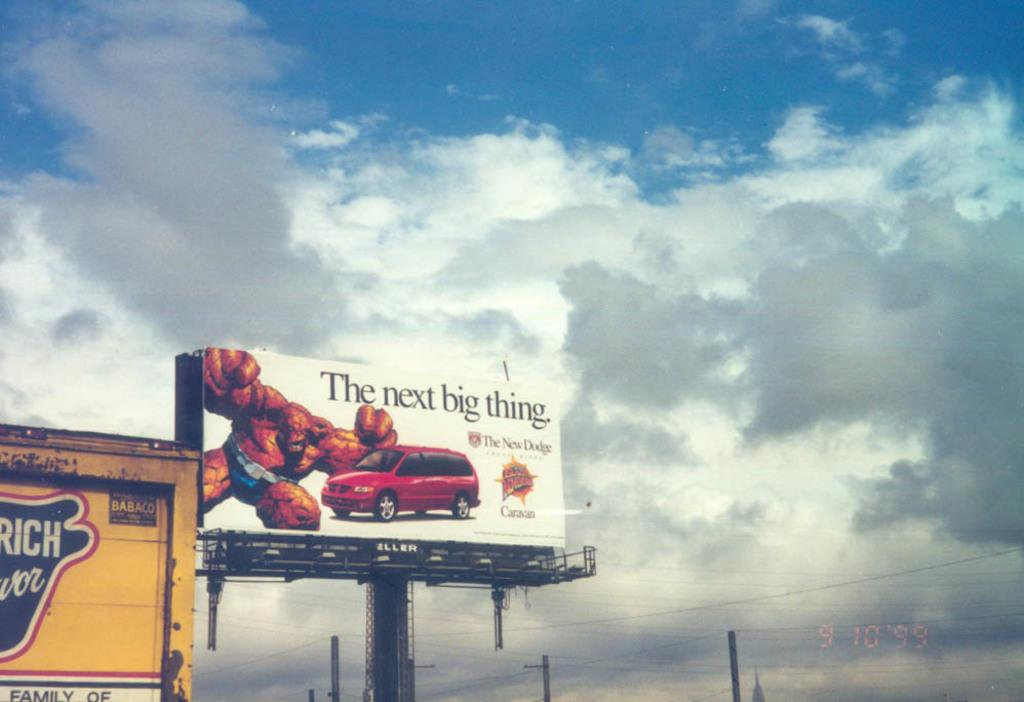<image>
Write a terse but informative summary of the picture. A billboard for the New Dodge has a picture of a red van on it. 